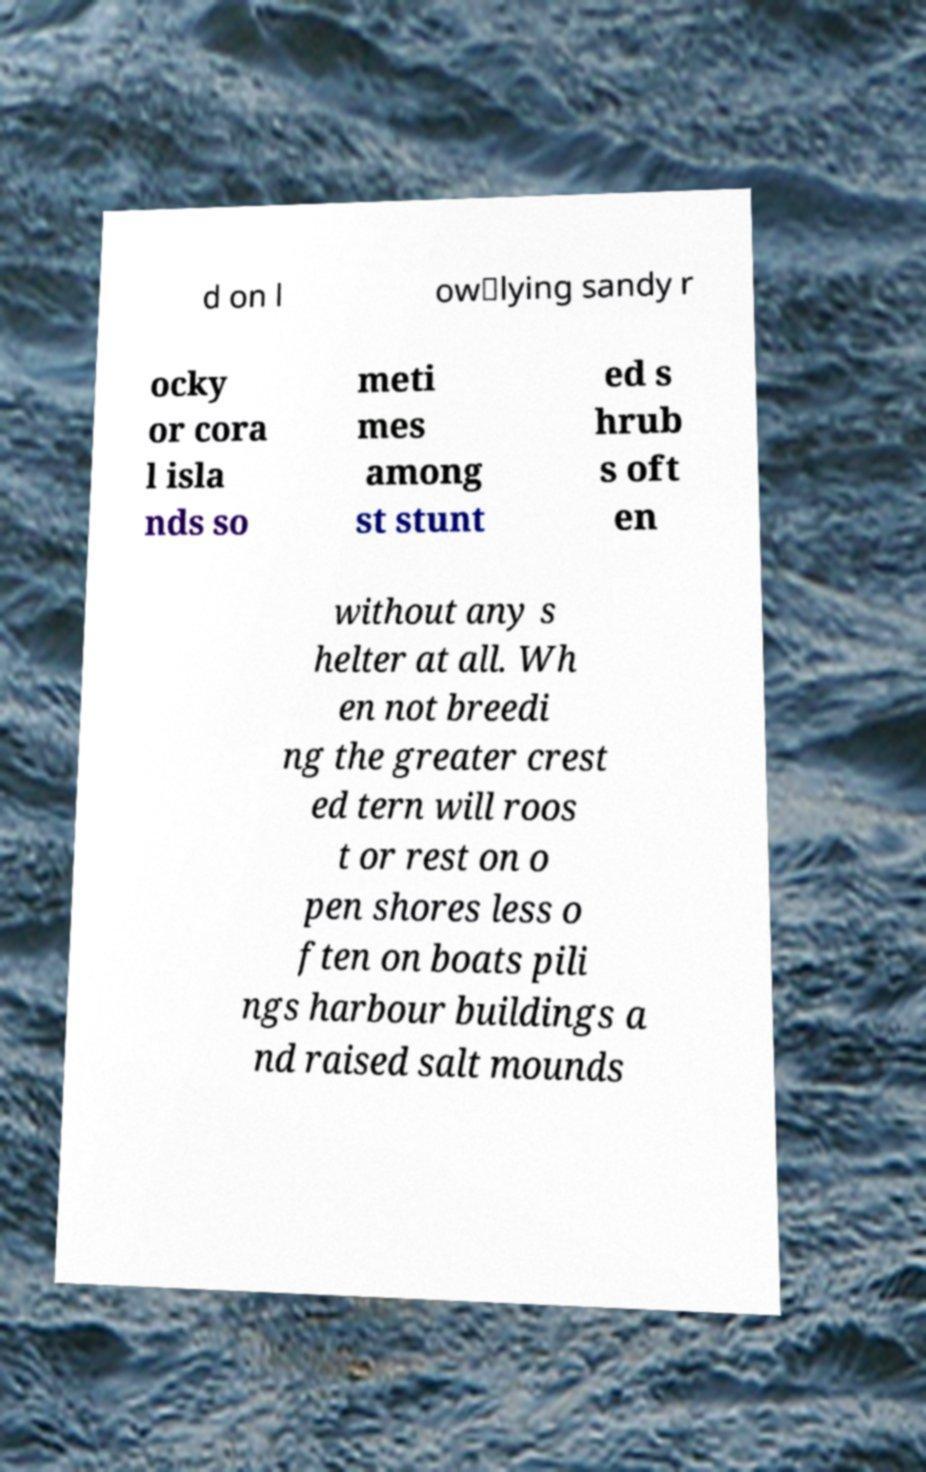For documentation purposes, I need the text within this image transcribed. Could you provide that? d on l ow‑lying sandy r ocky or cora l isla nds so meti mes among st stunt ed s hrub s oft en without any s helter at all. Wh en not breedi ng the greater crest ed tern will roos t or rest on o pen shores less o ften on boats pili ngs harbour buildings a nd raised salt mounds 